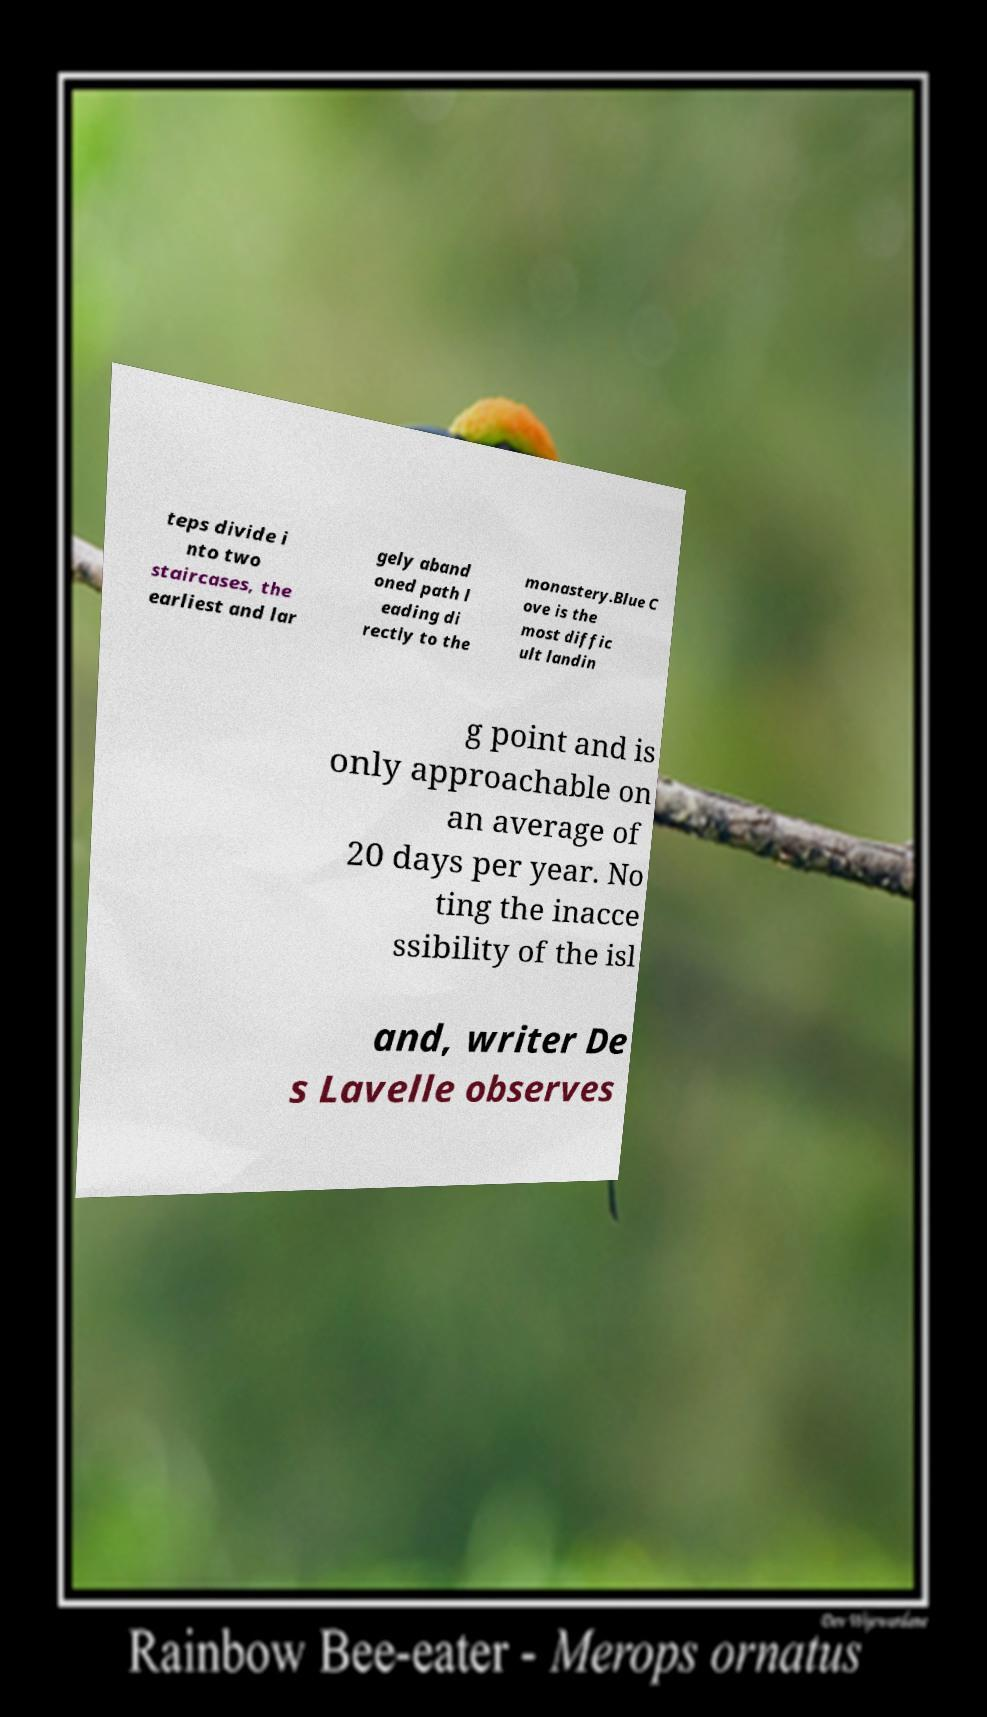Please identify and transcribe the text found in this image. teps divide i nto two staircases, the earliest and lar gely aband oned path l eading di rectly to the monastery.Blue C ove is the most diffic ult landin g point and is only approachable on an average of 20 days per year. No ting the inacce ssibility of the isl and, writer De s Lavelle observes 